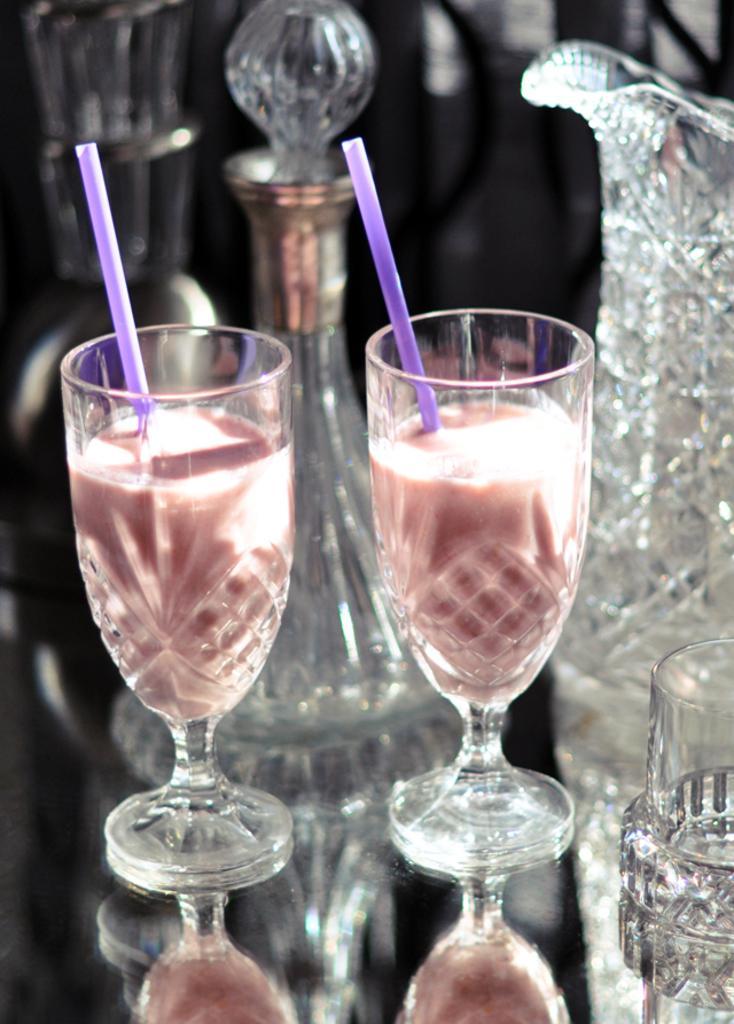Could you give a brief overview of what you see in this image? In the image we can see two glasses, in the glass we can see the liquid and straw. Here we can see the reflection of the glass and the background is slightly blurred.  